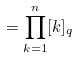<formula> <loc_0><loc_0><loc_500><loc_500>= \prod _ { k = 1 } ^ { n } [ k ] _ { q }</formula> 